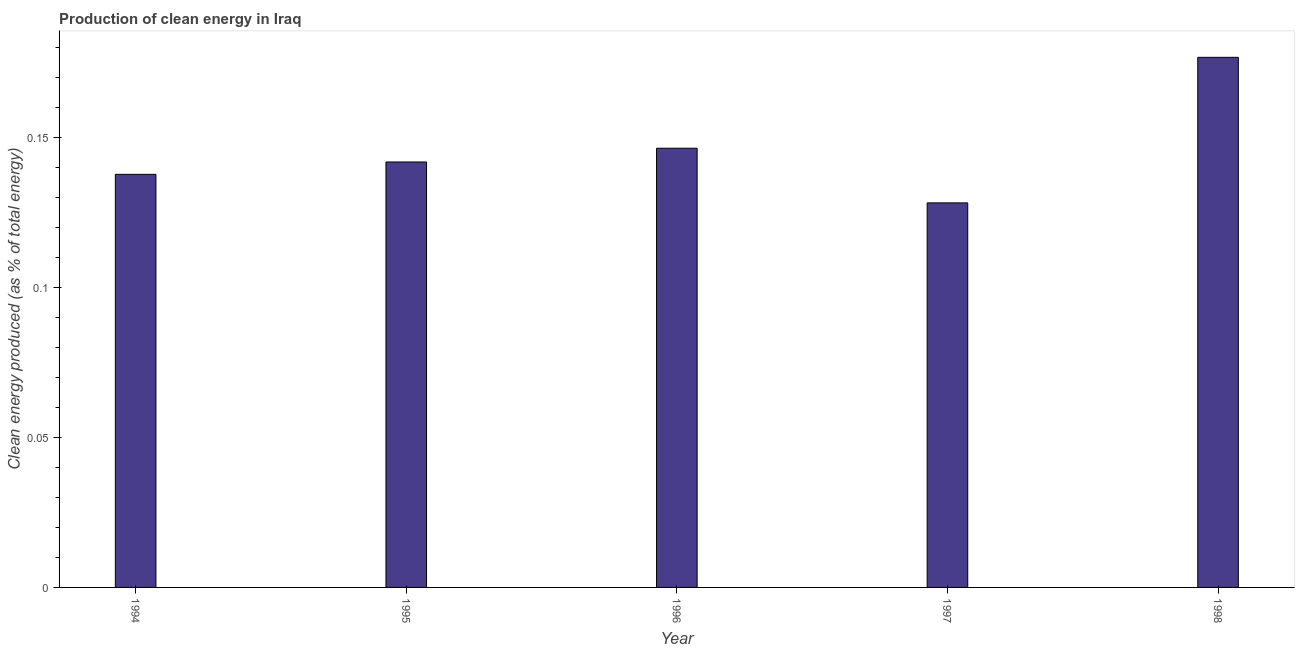Does the graph contain any zero values?
Offer a terse response. No. Does the graph contain grids?
Your answer should be compact. No. What is the title of the graph?
Make the answer very short. Production of clean energy in Iraq. What is the label or title of the Y-axis?
Your response must be concise. Clean energy produced (as % of total energy). What is the production of clean energy in 1996?
Provide a short and direct response. 0.15. Across all years, what is the maximum production of clean energy?
Provide a short and direct response. 0.18. Across all years, what is the minimum production of clean energy?
Your answer should be compact. 0.13. In which year was the production of clean energy maximum?
Your answer should be compact. 1998. What is the sum of the production of clean energy?
Your answer should be compact. 0.73. What is the difference between the production of clean energy in 1995 and 1997?
Keep it short and to the point. 0.01. What is the average production of clean energy per year?
Your answer should be compact. 0.15. What is the median production of clean energy?
Your answer should be compact. 0.14. Do a majority of the years between 1995 and 1997 (inclusive) have production of clean energy greater than 0.08 %?
Offer a very short reply. Yes. What is the ratio of the production of clean energy in 1996 to that in 1997?
Offer a terse response. 1.14. Is the difference between the production of clean energy in 1996 and 1998 greater than the difference between any two years?
Offer a terse response. No. What is the difference between the highest and the second highest production of clean energy?
Your response must be concise. 0.03. What is the difference between the highest and the lowest production of clean energy?
Keep it short and to the point. 0.05. In how many years, is the production of clean energy greater than the average production of clean energy taken over all years?
Provide a succinct answer. 2. Are all the bars in the graph horizontal?
Your answer should be very brief. No. How many years are there in the graph?
Ensure brevity in your answer.  5. Are the values on the major ticks of Y-axis written in scientific E-notation?
Offer a very short reply. No. What is the Clean energy produced (as % of total energy) of 1994?
Give a very brief answer. 0.14. What is the Clean energy produced (as % of total energy) of 1995?
Your response must be concise. 0.14. What is the Clean energy produced (as % of total energy) in 1996?
Keep it short and to the point. 0.15. What is the Clean energy produced (as % of total energy) in 1997?
Make the answer very short. 0.13. What is the Clean energy produced (as % of total energy) in 1998?
Your answer should be very brief. 0.18. What is the difference between the Clean energy produced (as % of total energy) in 1994 and 1995?
Provide a short and direct response. -0. What is the difference between the Clean energy produced (as % of total energy) in 1994 and 1996?
Offer a very short reply. -0.01. What is the difference between the Clean energy produced (as % of total energy) in 1994 and 1997?
Provide a succinct answer. 0.01. What is the difference between the Clean energy produced (as % of total energy) in 1994 and 1998?
Make the answer very short. -0.04. What is the difference between the Clean energy produced (as % of total energy) in 1995 and 1996?
Provide a succinct answer. -0. What is the difference between the Clean energy produced (as % of total energy) in 1995 and 1997?
Provide a succinct answer. 0.01. What is the difference between the Clean energy produced (as % of total energy) in 1995 and 1998?
Your answer should be very brief. -0.03. What is the difference between the Clean energy produced (as % of total energy) in 1996 and 1997?
Provide a short and direct response. 0.02. What is the difference between the Clean energy produced (as % of total energy) in 1996 and 1998?
Your answer should be compact. -0.03. What is the difference between the Clean energy produced (as % of total energy) in 1997 and 1998?
Provide a short and direct response. -0.05. What is the ratio of the Clean energy produced (as % of total energy) in 1994 to that in 1995?
Ensure brevity in your answer.  0.97. What is the ratio of the Clean energy produced (as % of total energy) in 1994 to that in 1996?
Your response must be concise. 0.94. What is the ratio of the Clean energy produced (as % of total energy) in 1994 to that in 1997?
Keep it short and to the point. 1.07. What is the ratio of the Clean energy produced (as % of total energy) in 1994 to that in 1998?
Provide a short and direct response. 0.78. What is the ratio of the Clean energy produced (as % of total energy) in 1995 to that in 1997?
Your answer should be very brief. 1.11. What is the ratio of the Clean energy produced (as % of total energy) in 1995 to that in 1998?
Your answer should be very brief. 0.8. What is the ratio of the Clean energy produced (as % of total energy) in 1996 to that in 1997?
Your response must be concise. 1.14. What is the ratio of the Clean energy produced (as % of total energy) in 1996 to that in 1998?
Provide a short and direct response. 0.83. What is the ratio of the Clean energy produced (as % of total energy) in 1997 to that in 1998?
Give a very brief answer. 0.72. 